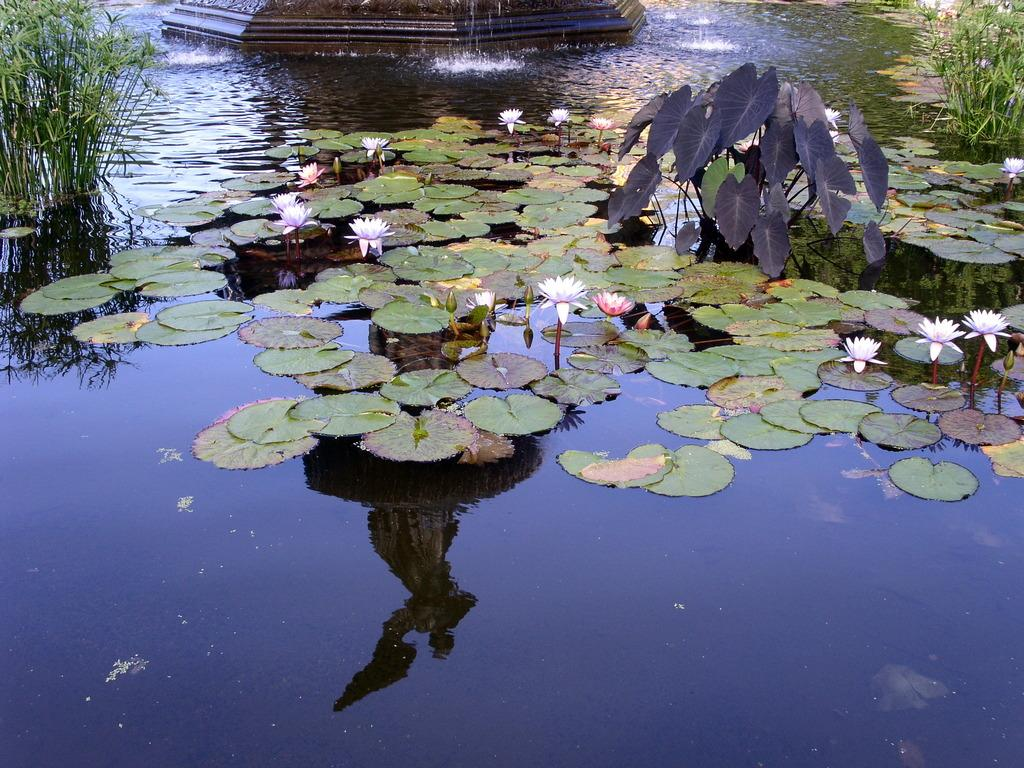What type of vegetation can be seen in the image? There are leaves, flowers, and plants visible in the image. What else can be seen in the image besides vegetation? There is water visible in the image. What song is being sung by the flowers in the image? There is no indication in the image that the flowers are singing a song, as flowers do not have the ability to sing. 